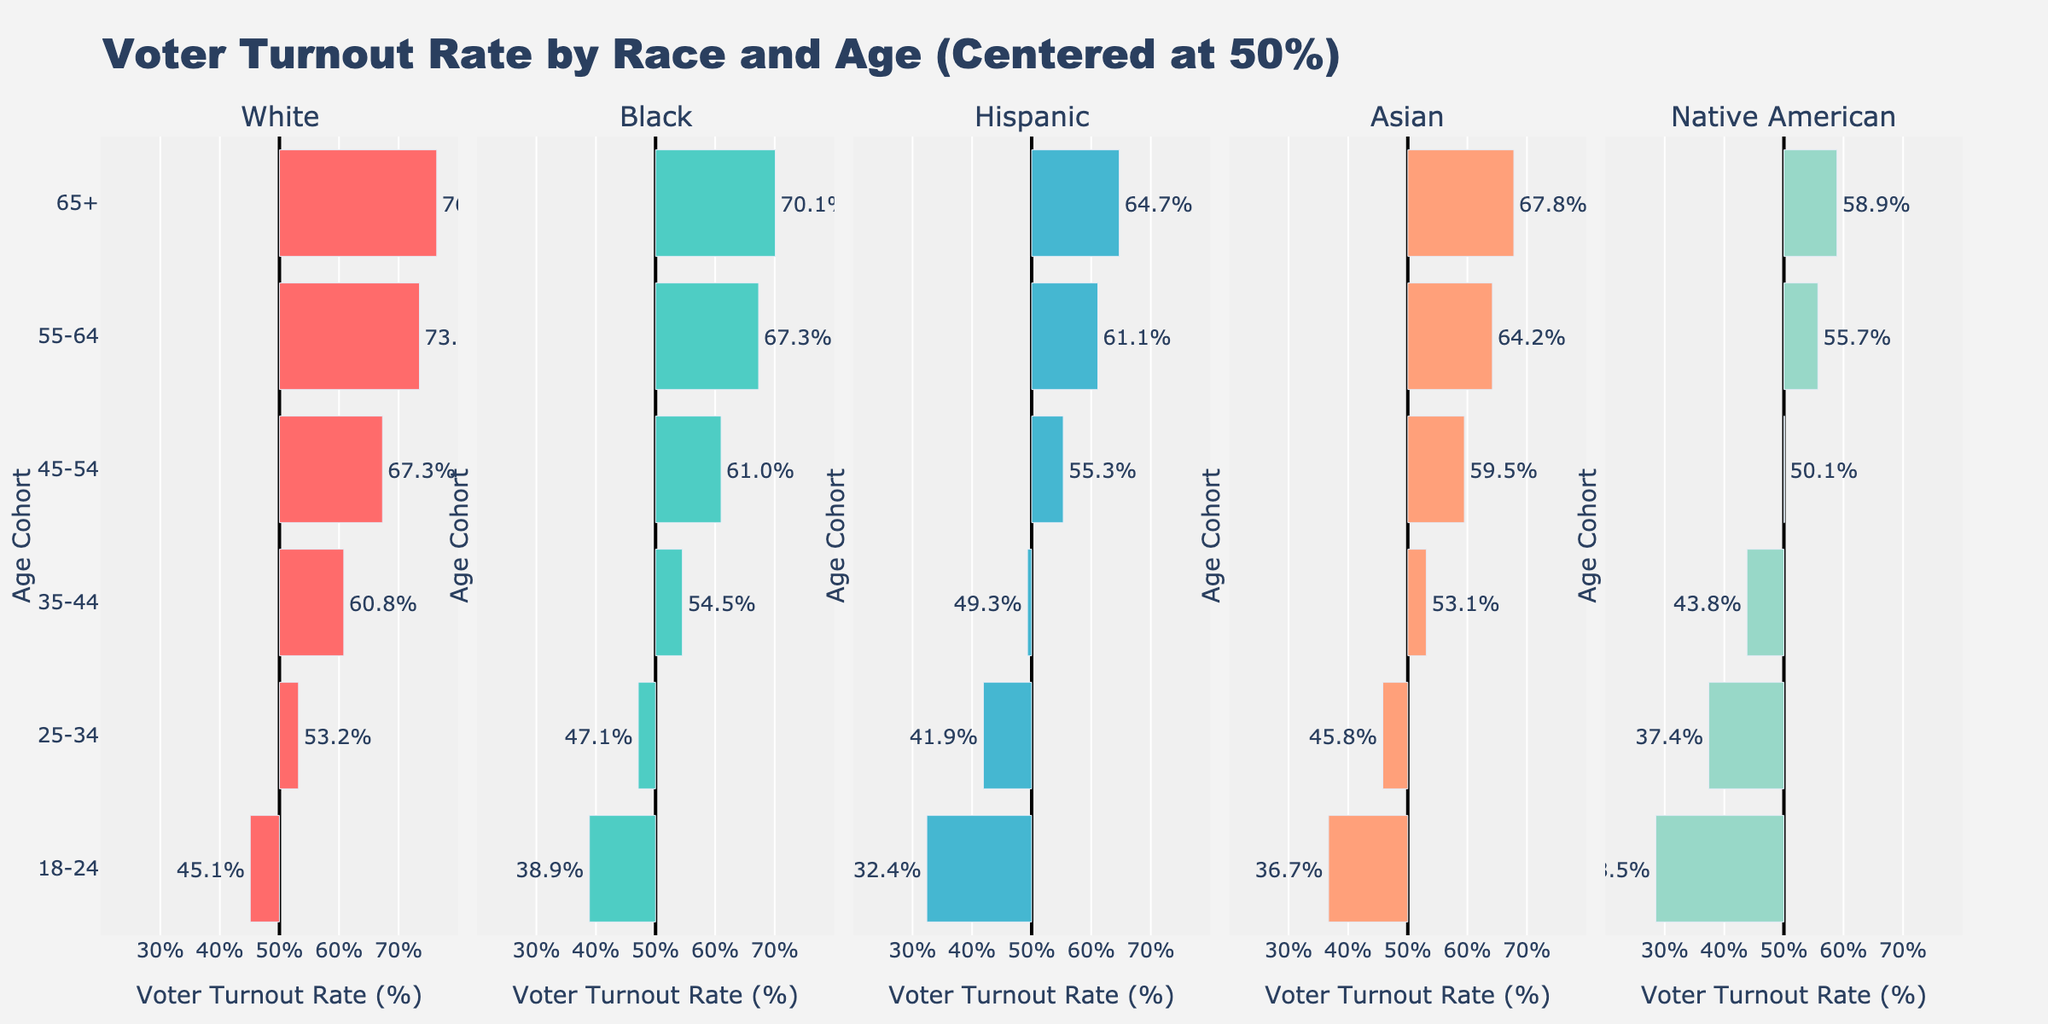Which age cohort has the highest voter turnout rate among White citizens? To determine this, we need to look at the lengths of the bars for the White race section. The longest bar represents the 65+ age cohort with a voter turnout rate centered at 50%, going up to 76.4%.
Answer: 65+ Which race has the lowest voter turnout rate in the 18-24 age cohort? We need to identify the shortest bar in the 18-24 age cohort across all races. The Native American bar appears to be the shortest, indicating a voter turnout rate of 28.5%, centered at 50%.
Answer: Native American Compare the voter turnout rates between Black and Asian citizens in the 35-44 age cohort. Which one is higher? For this, we should compare the lengths of the bars for the 35-44 age cohort in the Black and Asian sections. Black citizens have a voter turnout rate of 54.5%, while Asian citizens have a rate of 53.1%.
Answer: Black Calculate the difference in voter turnout rates between Hispanic citizens aged 25-34 and White citizens aged 25-34. Look at the bars for the 25-34 age cohort in both the Hispanic and White sections. Hispanic voter turnout is 41.9%, and White voter turnout is 53.2%. The difference is 53.2% - 41.9%.
Answer: 11.3% Which age cohort shows the most significant increase in voter turnout rate for Asian citizens compared to the previous age cohort? Examine the gaps between the bars in consecutive age cohorts for Asian citizens. The jump from 18-24 (36.7%) to 25-34 (45.8%) is the largest increase of 9.1%.
Answer: 18-24 to 25-34 For Native American citizens, is there any age cohort with a voter turnout rate higher than 60%? Check the bars representing Native Americans for all age cohorts. The highest bar is for the 65+ cohort, with a voter turnout rate of 58.9%. There is no cohort over 60%.
Answer: No What's the average voter turnout rate for Black citizens across all age cohorts shown? First, sum the turnout rates for each Black age cohort: 38.9% + 47.1% + 54.5% + 61% + 67.3% + 70.1%. The total is 338.9%, and there are six cohorts. Average = 338.9% / 6.
Answer: 56.5% How does the voter turnout rate for Hispanic citizens aged 65+ compare to Black citizens aged 65+? Compare the lengths of the bars for the 65+ age cohort in both Hispanic and Black races. Hispanic citizens have a turnout rate of 64.7%, while Black citizens have a turnout rate of 70.1%.
Answer: Lower 